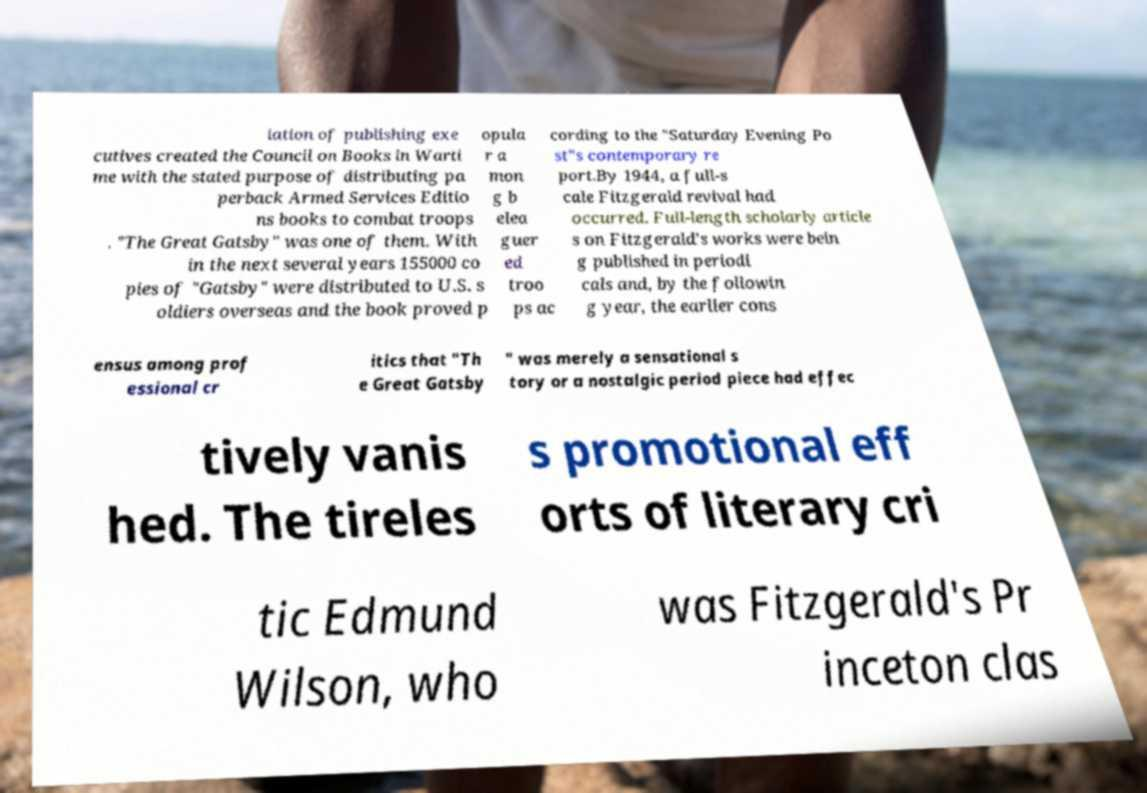I need the written content from this picture converted into text. Can you do that? iation of publishing exe cutives created the Council on Books in Warti me with the stated purpose of distributing pa perback Armed Services Editio ns books to combat troops . "The Great Gatsby" was one of them. With in the next several years 155000 co pies of "Gatsby" were distributed to U.S. s oldiers overseas and the book proved p opula r a mon g b elea guer ed troo ps ac cording to the "Saturday Evening Po st"s contemporary re port.By 1944, a full-s cale Fitzgerald revival had occurred. Full-length scholarly article s on Fitzgerald's works were bein g published in periodi cals and, by the followin g year, the earlier cons ensus among prof essional cr itics that "Th e Great Gatsby " was merely a sensational s tory or a nostalgic period piece had effec tively vanis hed. The tireles s promotional eff orts of literary cri tic Edmund Wilson, who was Fitzgerald's Pr inceton clas 